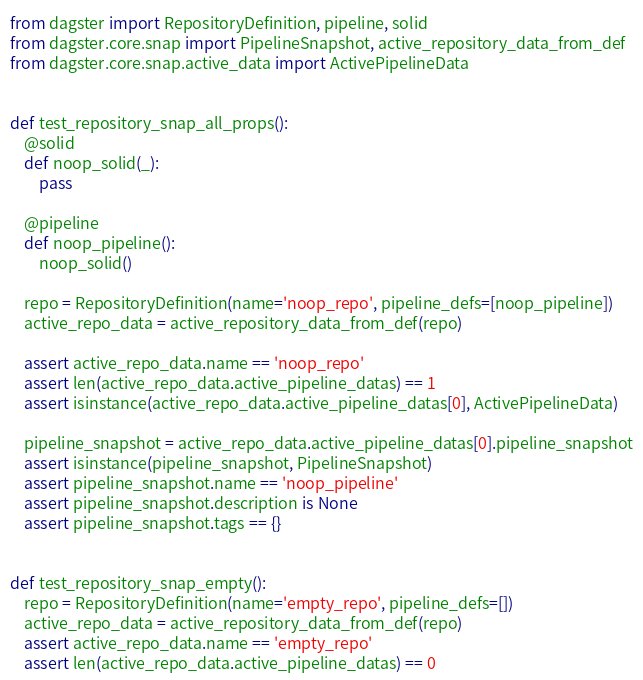<code> <loc_0><loc_0><loc_500><loc_500><_Python_>from dagster import RepositoryDefinition, pipeline, solid
from dagster.core.snap import PipelineSnapshot, active_repository_data_from_def
from dagster.core.snap.active_data import ActivePipelineData


def test_repository_snap_all_props():
    @solid
    def noop_solid(_):
        pass

    @pipeline
    def noop_pipeline():
        noop_solid()

    repo = RepositoryDefinition(name='noop_repo', pipeline_defs=[noop_pipeline])
    active_repo_data = active_repository_data_from_def(repo)

    assert active_repo_data.name == 'noop_repo'
    assert len(active_repo_data.active_pipeline_datas) == 1
    assert isinstance(active_repo_data.active_pipeline_datas[0], ActivePipelineData)

    pipeline_snapshot = active_repo_data.active_pipeline_datas[0].pipeline_snapshot
    assert isinstance(pipeline_snapshot, PipelineSnapshot)
    assert pipeline_snapshot.name == 'noop_pipeline'
    assert pipeline_snapshot.description is None
    assert pipeline_snapshot.tags == {}


def test_repository_snap_empty():
    repo = RepositoryDefinition(name='empty_repo', pipeline_defs=[])
    active_repo_data = active_repository_data_from_def(repo)
    assert active_repo_data.name == 'empty_repo'
    assert len(active_repo_data.active_pipeline_datas) == 0
</code> 